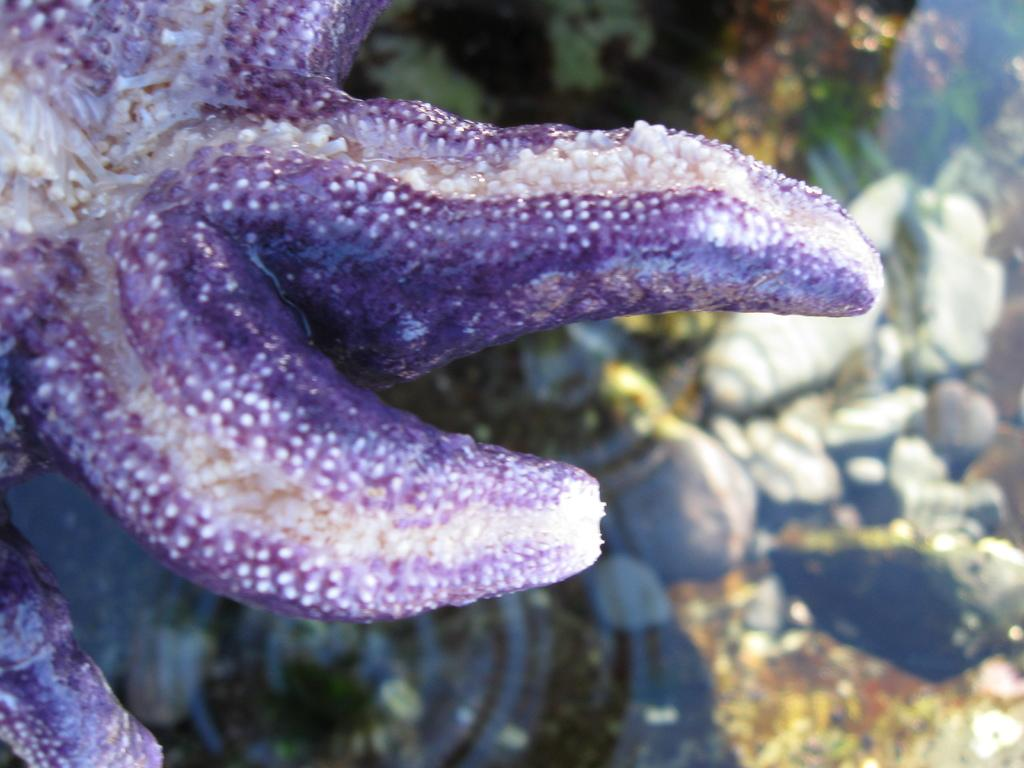What is the main subject of the image? There is a starfish in the image. Can you describe any other objects in the image? There are some objects in the image, but their specific details are not mentioned in the provided facts. Is there a baby holding an umbrella in the image? There is no mention of a baby or an umbrella in the provided facts, so we cannot confirm their presence in the image. 